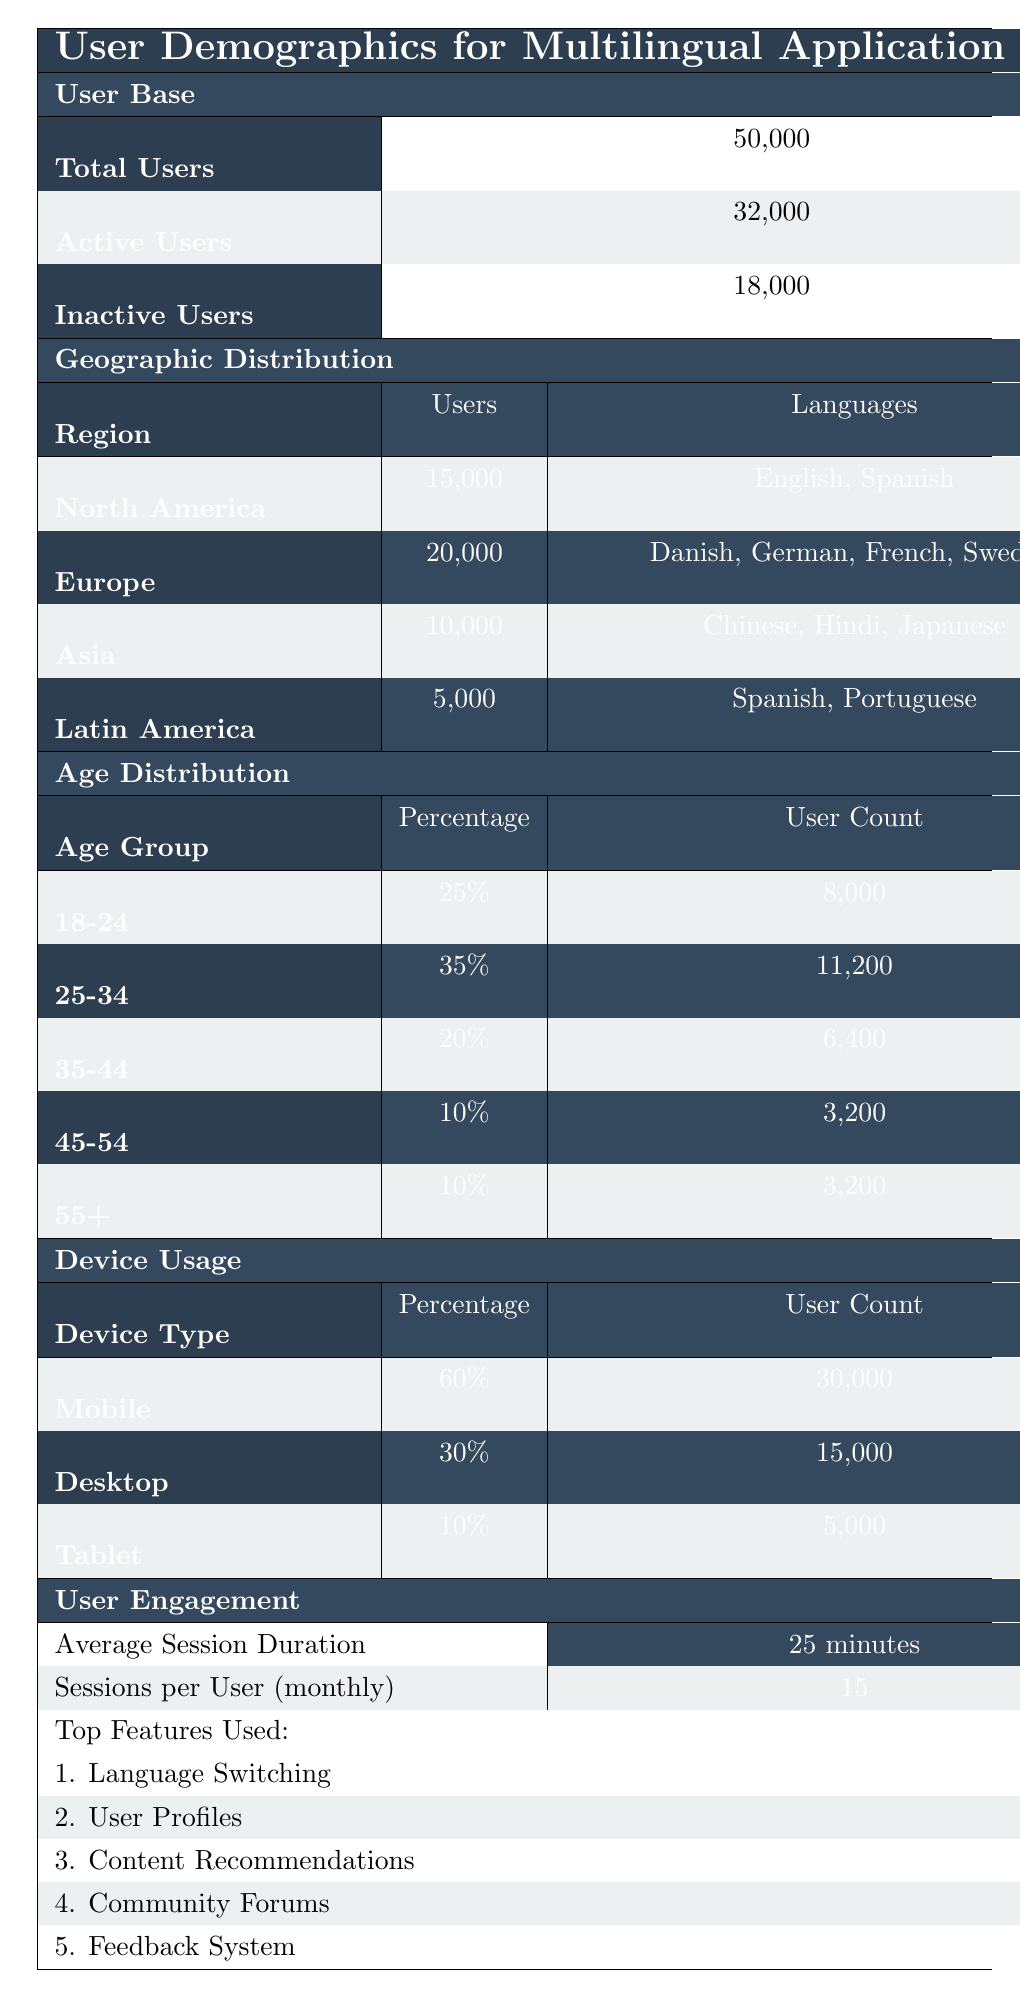What is the total number of users? The total number of users is given directly in the table under the "User Base" section. It states that there are 50,000 total users.
Answer: 50,000 How many active users are there? The number of active users can be found in the same "User Base" section. It shows 32,000 active users.
Answer: 32,000 What is the percentage of users from Europe? The number of users from Europe is specified as 20,000, while the total user count is 50,000. To find the percentage, we calculate (20,000 / 50,000) * 100 = 40%.
Answer: 40% How many users are using mobile devices? The table specifies that there are 30,000 users on mobile devices under the "Device Usage" section.
Answer: 30,000 What is the average session duration of users? The table indicates the average session duration under the "User Engagement" section, which states it is 25 minutes.
Answer: 25 minutes What is the age group with the highest user count? The age distribution shows that the "25-34" age group has the highest user count at 11,200, which is more than any other group.
Answer: 25-34 How many inactive users are there compared to active users? There are 18,000 inactive users and 32,000 active users. To compare, subtract: 32,000 - 18,000 = 14,000 more active users.
Answer: 14,000 Which region has the lowest number of users? In the "Geographic Distribution" section, Latin America has the lowest number of users at 5,000.
Answer: Latin America What percentage of users are between the ages of 18-34? We add the percentages of users aged 18-24 (25%) and 25-34 (35%): 25% + 35% = 60%. Therefore, 60% of users are aged 18-34.
Answer: 60% Is there any region where users speak only one language? The Latin America region speaks Spanish and Portuguese, while North America speaks English and Spanish. No region is listed with only one language, so the answer is no.
Answer: No What is the total number of users from North America and Asia combined? North America has 15,000 users, and Asia has 10,000. Adding these together gives: 15,000 + 10,000 = 25,000.
Answer: 25,000 What devices do the majority of users prefer? By looking at the "Device Usage" section, mobile devices are preferred by 60% of users, which is the highest percentage compared to desktop and tablet.
Answer: Mobile What is the total user count for age groups 45-54 and 55+ combined? The age group 45-54 has 3,200 users and the 55+ group also has 3,200 users. Adding these gives: 3,200 + 3,200 = 6,400.
Answer: 6,400 Which top feature has the highest user engagement? The top features are listed, but the table does not indicate specific engagement metrics for each feature. However, "Language Switching" appears first, suggesting it may have the highest engagement.
Answer: Language Switching How many users are using tablets? The table indicates under "Device Usage" that there are 5,000 users on tablets.
Answer: 5,000 